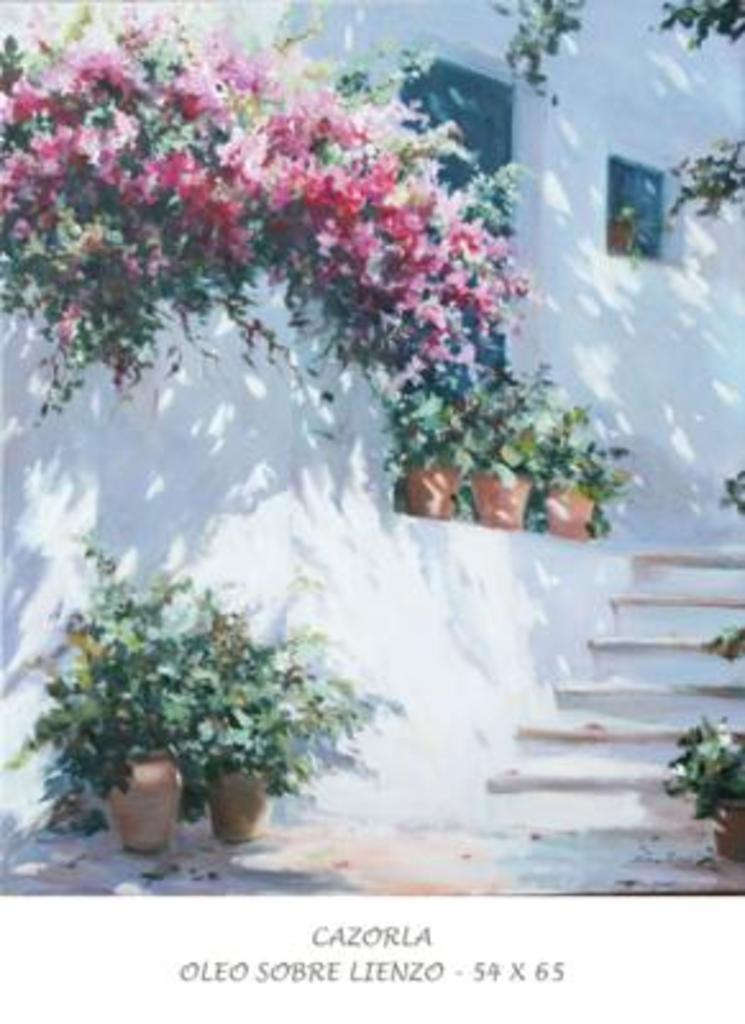What type of building is visible in the image? There is a house in the image. What can be found inside the house? The house has house plants. Are there any natural elements present in the image? Yes, there are flowers in the image. What architectural feature is visible in the house? There is a staircase in the image. What type of garden can be seen on the tray in the image? There is no tray or garden present in the image. 